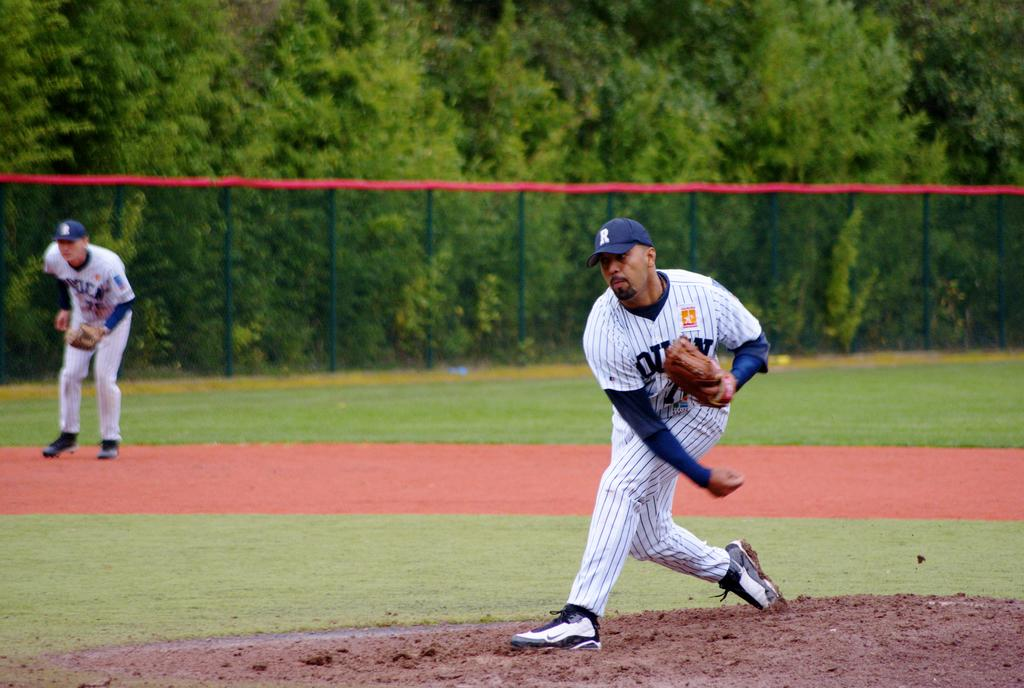<image>
Relay a brief, clear account of the picture shown. a man with a blue cap with a letter R on it pitches a ball. 